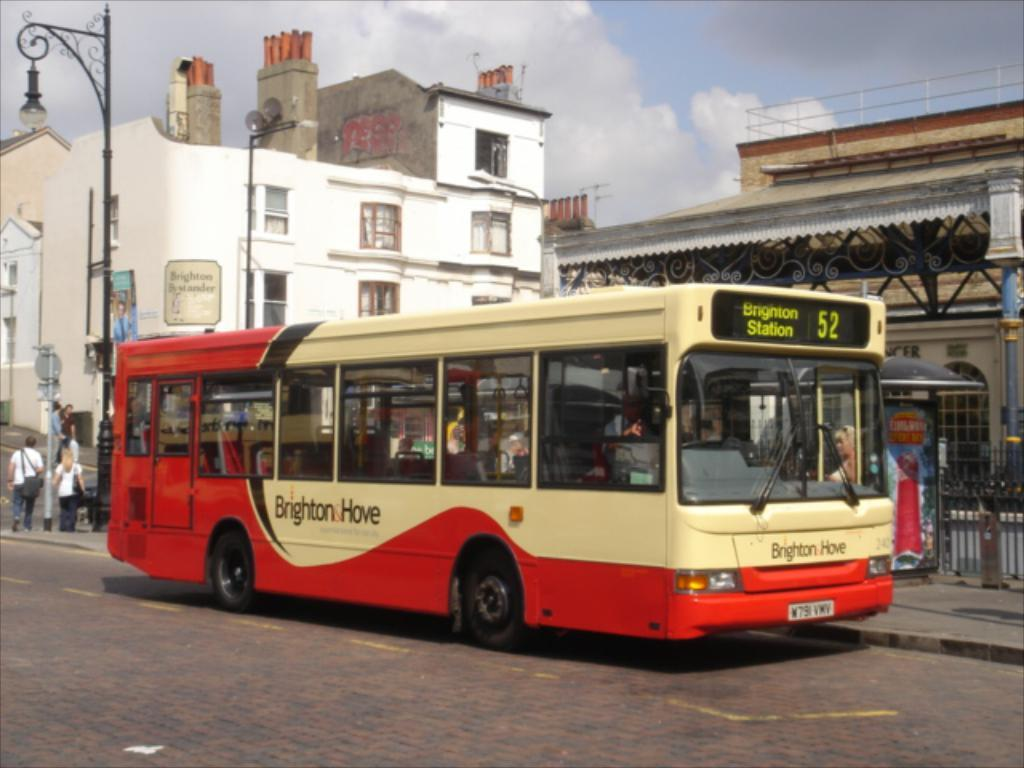<image>
Offer a succinct explanation of the picture presented. a bus with the sign of brigton hove on a side 